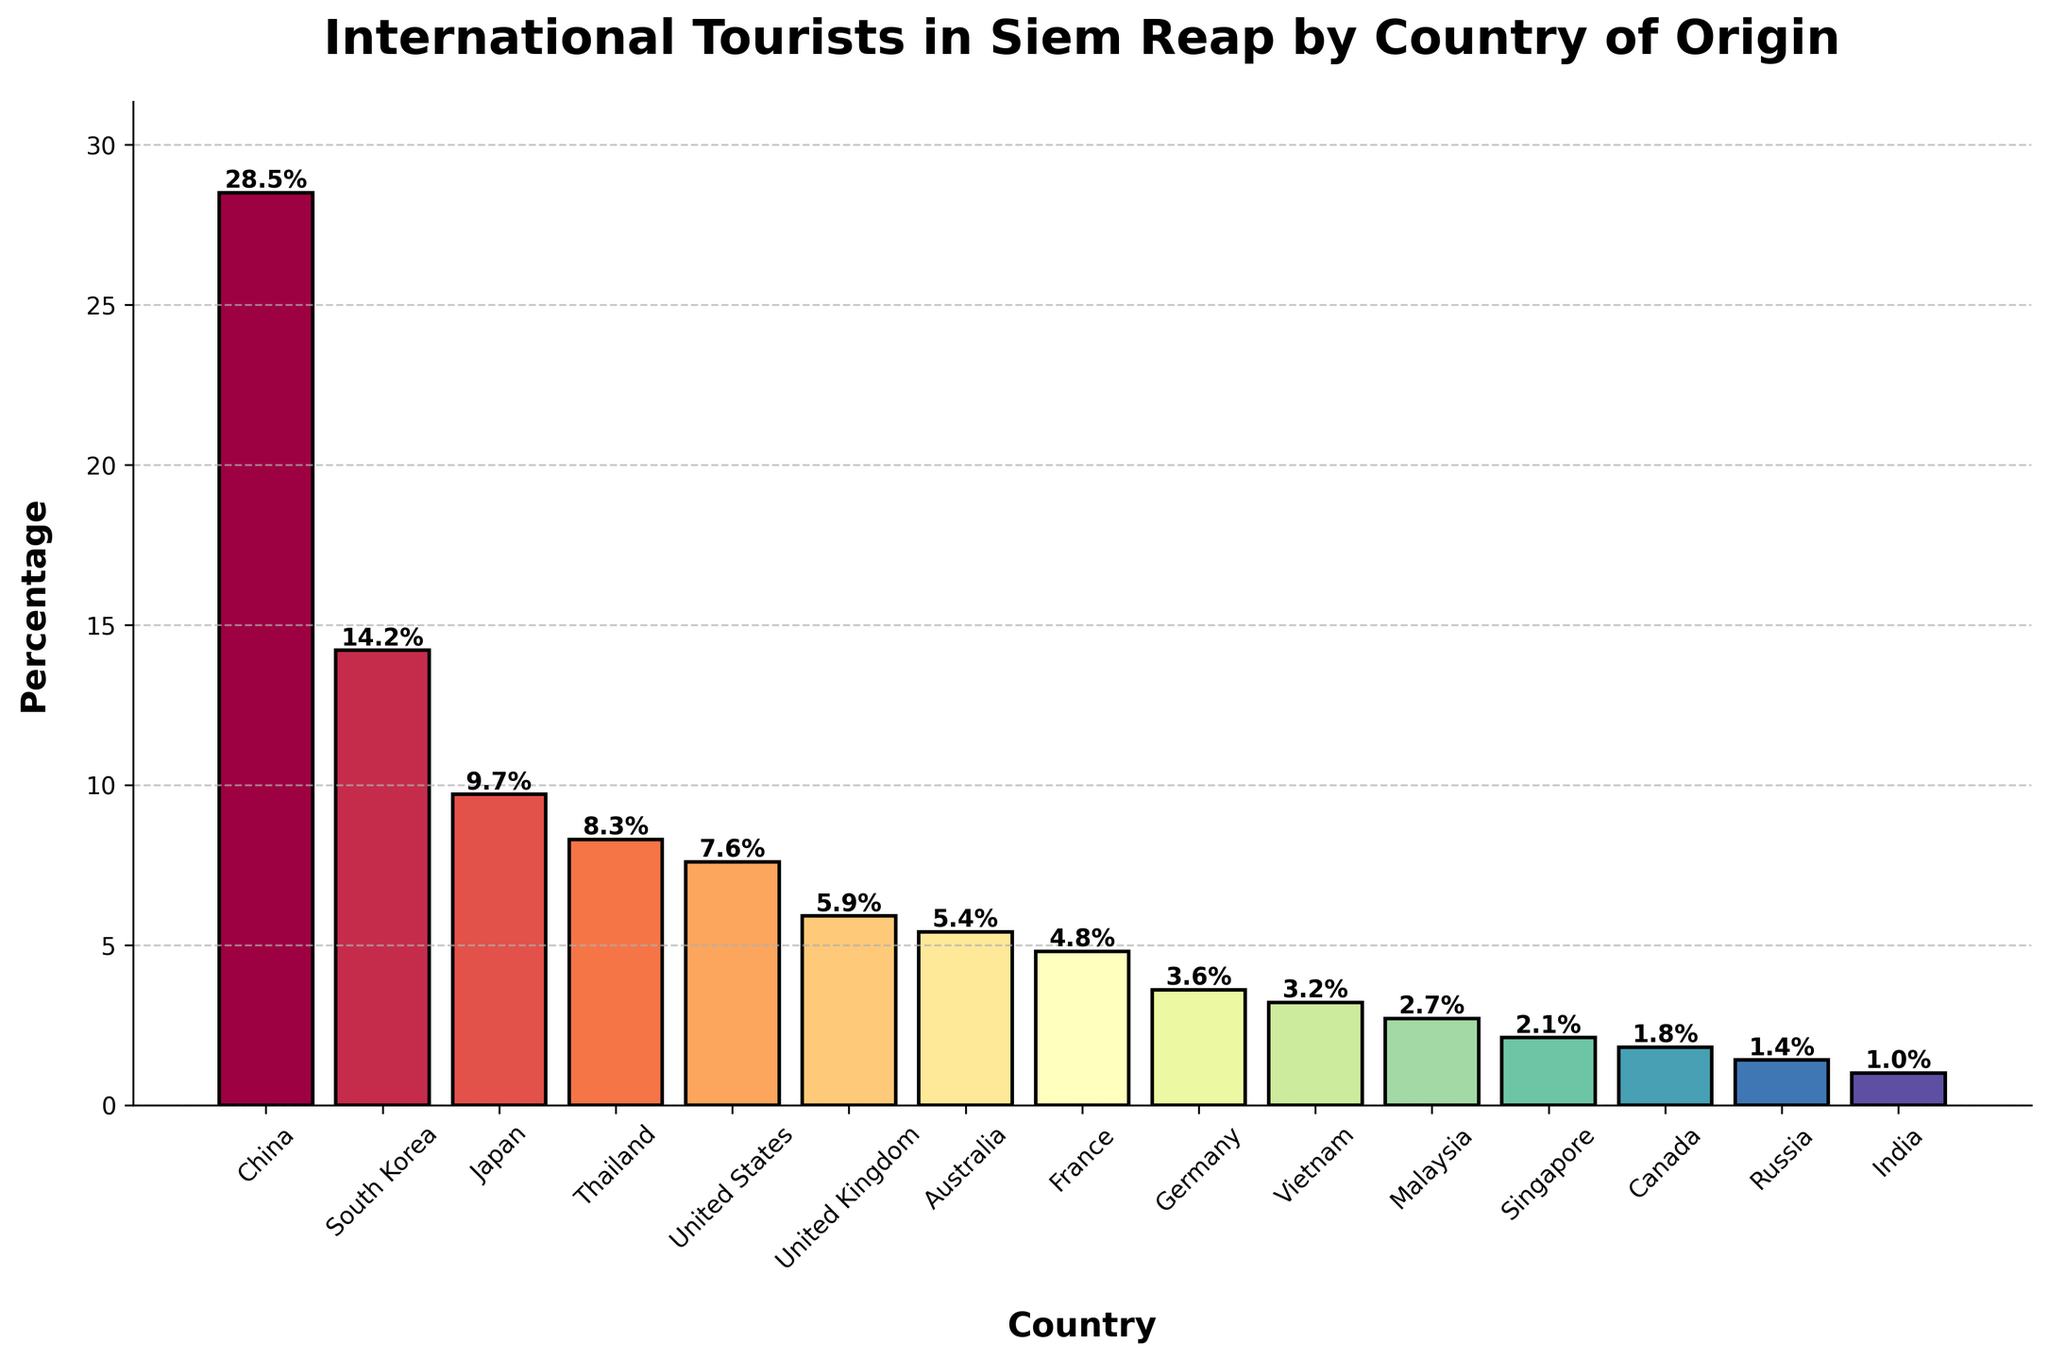Which country has the highest percentage of tourists visiting Siem Reap? The bar for China is the tallest in the chart, indicating it has the highest percentage.
Answer: China What's the total percentage of tourists from South Korea, Japan, and Thailand combined? Add the percentages for South Korea (14.2%), Japan (9.7%), and Thailand (8.3%). The sum is 14.2 + 9.7 + 8.3 = 32.2%.
Answer: 32.2% Which country has a higher percentage of tourists visiting Siem Reap, the United States or the United Kingdom? Compare the heights of the bars for the United States (7.6%) and the United Kingdom (5.9%). The United States has a higher percentage.
Answer: United States Which two countries have the closest percentages of international tourists visiting Siem Reap? Look for bars that have similar heights. Australia's 5.4% and the United Kingdom's 5.9% are the closest.
Answer: Australia and United Kingdom What's the total percentage of tourists from all the Asian countries listed? Add the percentages for China (28.5%), South Korea (14.2%), Japan (9.7%), Thailand (8.3%), Vietnam (3.2%), Malaysia (2.7%), Singapore (2.1%), and India (1.0%). The sum is 28.5 + 14.2 + 9.7 + 8.3 + 3.2 + 2.7 + 2.1 + 1.0 = 69.7%.
Answer: 69.7% Which country's bar is the shortest in the chart? The bar for India is the shortest in the chart with a percentage of 1.0%.
Answer: India By how much does the percentage of tourists from France differ from the percentage of tourists from Germany? Subtract the percentage for Germany (3.6%) from the percentage for France (4.8%). The difference is 4.8 - 3.6 = 1.2%.
Answer: 1.2% What is the average percentage of tourists for Canada, Russia, and India? Add the percentages for Canada (1.8%), Russia (1.4%), and India (1.0%) and divide by 3. The calculation is (1.8 + 1.4 + 1.0) / 3 ≈ 1.4%.
Answer: 1.4% Which parameter is represented by the height of the bars in the chart? The vertical axis represents the percentage of international tourists visiting Siem Reap, so the height of the bars shows this percentage.
Answer: Percentage of tourists 